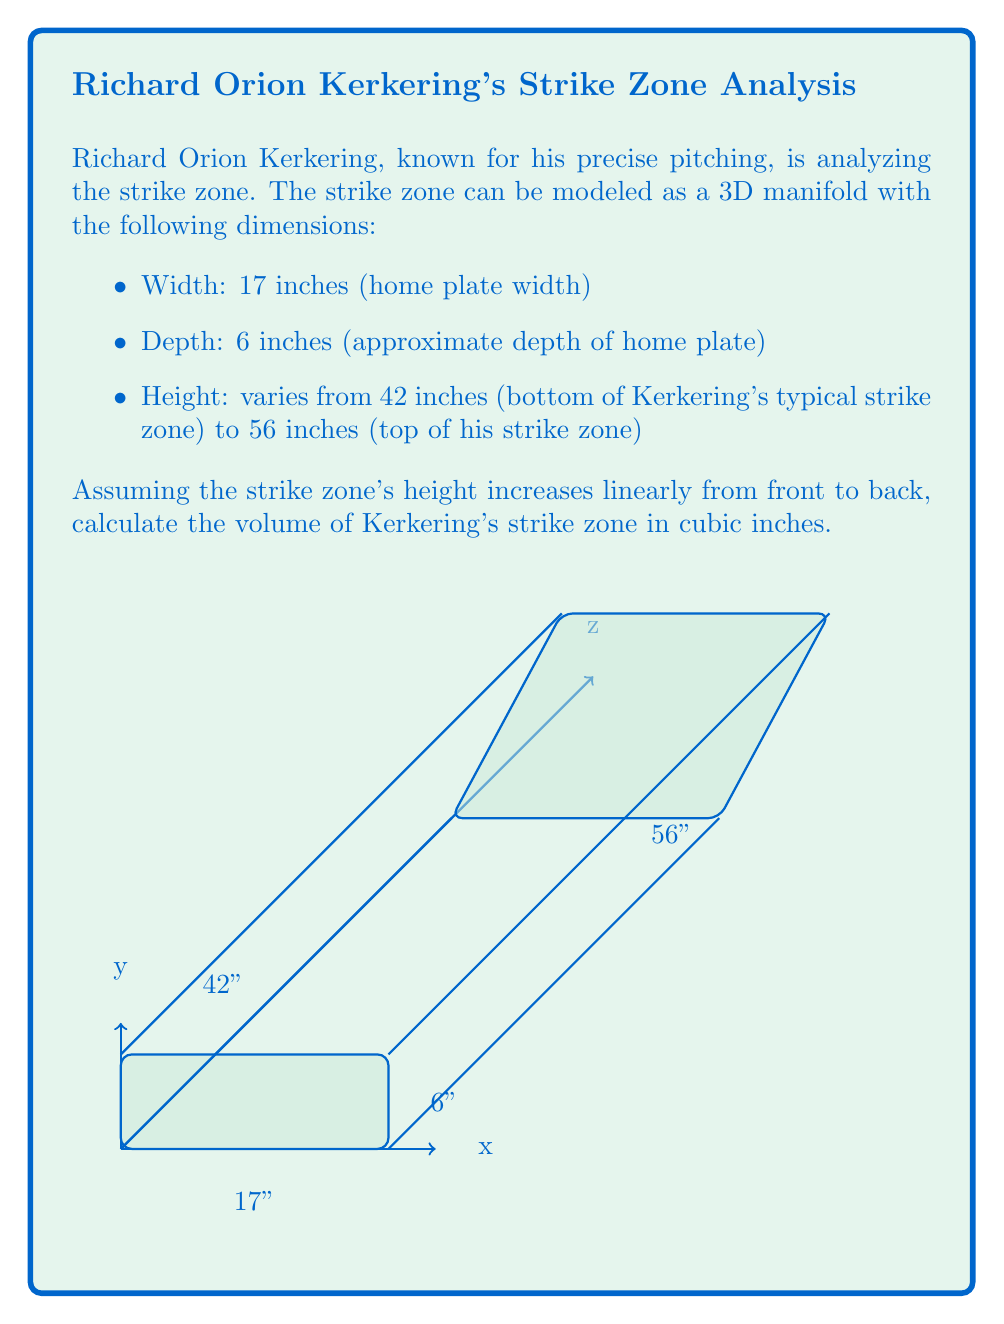Could you help me with this problem? To calculate the volume of Kerkering's strike zone, we need to consider it as a 3D manifold with varying height. Let's approach this step-by-step:

1) The strike zone is essentially a prism with a trapezoidal cross-section when viewed from the side.

2) We can calculate the volume using the formula for a trapezoidal prism:

   $$V = \frac{1}{2}(a + b)hw$$

   where $a$ and $b$ are the heights of the parallel sides, $h$ is the depth, and $w$ is the width.

3) In this case:
   $a = 42$ inches (front height)
   $b = 56$ inches (back height)
   $h = 6$ inches (depth)
   $w = 17$ inches (width)

4) Plugging these values into our formula:

   $$V = \frac{1}{2}(42 + 56) \times 6 \times 17$$

5) Simplifying:
   $$V = 49 \times 6 \times 17$$
   $$V = 4998$$ cubic inches

Therefore, the volume of Kerkering's strike zone is 4998 cubic inches.
Answer: 4998 cubic inches 